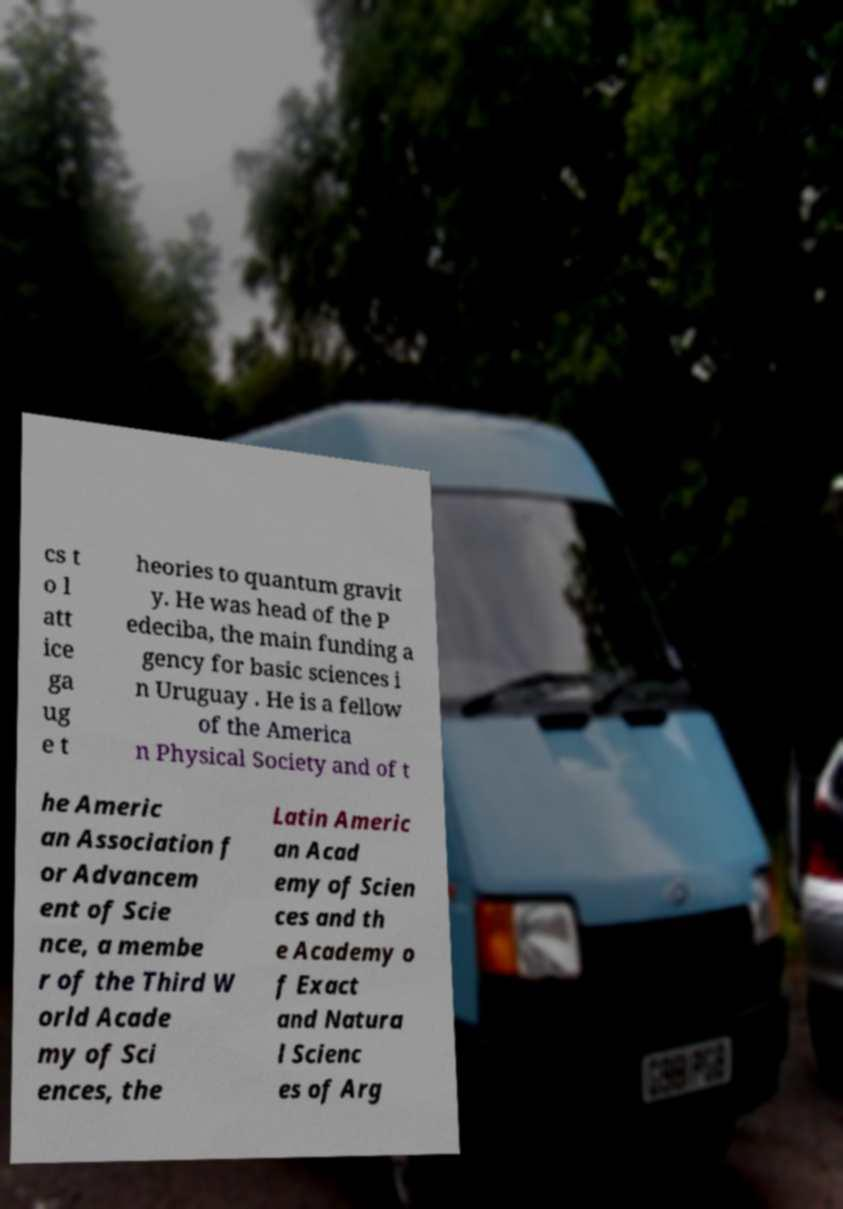Could you assist in decoding the text presented in this image and type it out clearly? cs t o l att ice ga ug e t heories to quantum gravit y. He was head of the P edeciba, the main funding a gency for basic sciences i n Uruguay . He is a fellow of the America n Physical Society and of t he Americ an Association f or Advancem ent of Scie nce, a membe r of the Third W orld Acade my of Sci ences, the Latin Americ an Acad emy of Scien ces and th e Academy o f Exact and Natura l Scienc es of Arg 